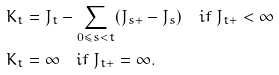Convert formula to latex. <formula><loc_0><loc_0><loc_500><loc_500>K _ { t } & = J _ { t } - \sum _ { 0 \leq s < t } ( J _ { s + } - J _ { s } ) \quad i f \ J _ { t + } < \infty \\ K _ { t } & = \infty \quad i f \ J _ { t + } = \infty .</formula> 